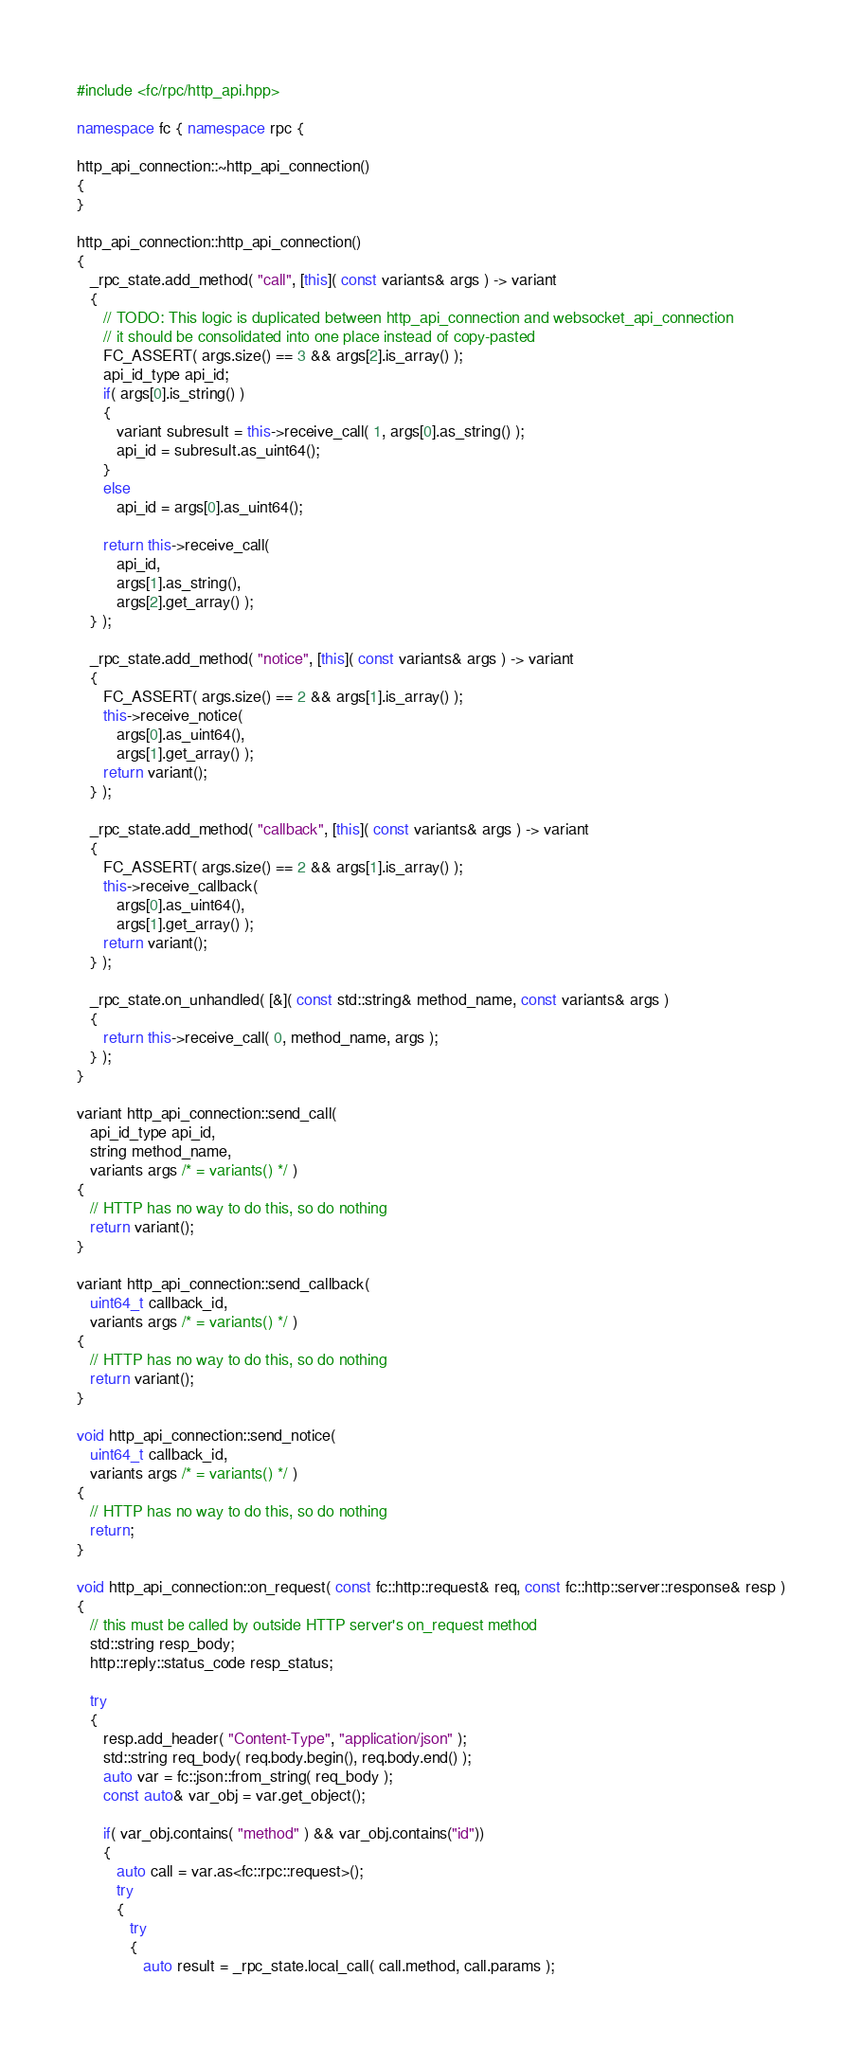<code> <loc_0><loc_0><loc_500><loc_500><_C++_>
#include <fc/rpc/http_api.hpp>

namespace fc { namespace rpc {

http_api_connection::~http_api_connection()
{
}

http_api_connection::http_api_connection()
{
   _rpc_state.add_method( "call", [this]( const variants& args ) -> variant
   {
      // TODO: This logic is duplicated between http_api_connection and websocket_api_connection
      // it should be consolidated into one place instead of copy-pasted
      FC_ASSERT( args.size() == 3 && args[2].is_array() );
      api_id_type api_id;
      if( args[0].is_string() )
      {
         variant subresult = this->receive_call( 1, args[0].as_string() );
         api_id = subresult.as_uint64();
      }
      else
         api_id = args[0].as_uint64();

      return this->receive_call(
         api_id,
         args[1].as_string(),
         args[2].get_array() );
   } );

   _rpc_state.add_method( "notice", [this]( const variants& args ) -> variant
   {
      FC_ASSERT( args.size() == 2 && args[1].is_array() );
      this->receive_notice(
         args[0].as_uint64(),
         args[1].get_array() );
      return variant();
   } );

   _rpc_state.add_method( "callback", [this]( const variants& args ) -> variant
   {
      FC_ASSERT( args.size() == 2 && args[1].is_array() );
      this->receive_callback(
         args[0].as_uint64(),
         args[1].get_array() );
      return variant();
   } );

   _rpc_state.on_unhandled( [&]( const std::string& method_name, const variants& args )
   {
      return this->receive_call( 0, method_name, args );
   } );
}

variant http_api_connection::send_call(
   api_id_type api_id,
   string method_name,
   variants args /* = variants() */ )
{
   // HTTP has no way to do this, so do nothing
   return variant();
}

variant http_api_connection::send_callback(
   uint64_t callback_id,
   variants args /* = variants() */ )
{
   // HTTP has no way to do this, so do nothing
   return variant();
}

void http_api_connection::send_notice(
   uint64_t callback_id,
   variants args /* = variants() */ )
{
   // HTTP has no way to do this, so do nothing
   return;
}

void http_api_connection::on_request( const fc::http::request& req, const fc::http::server::response& resp )
{
   // this must be called by outside HTTP server's on_request method
   std::string resp_body;
   http::reply::status_code resp_status;

   try
   {
      resp.add_header( "Content-Type", "application/json" );
      std::string req_body( req.body.begin(), req.body.end() );
      auto var = fc::json::from_string( req_body );
      const auto& var_obj = var.get_object();

      if( var_obj.contains( "method" ) && var_obj.contains("id"))
      {
         auto call = var.as<fc::rpc::request>();
         try
         {
            try
            {
               auto result = _rpc_state.local_call( call.method, call.params );</code> 